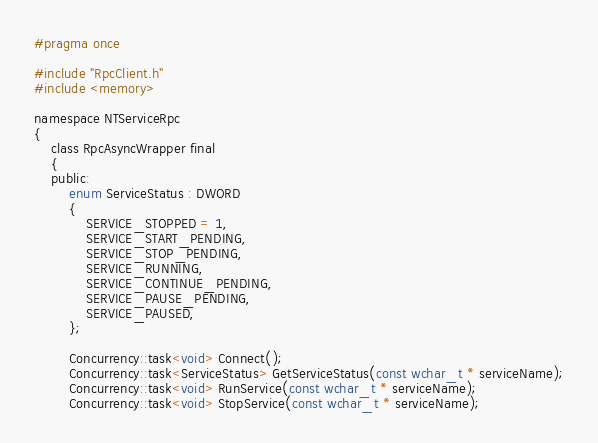<code> <loc_0><loc_0><loc_500><loc_500><_C_>#pragma once

#include "RpcClient.h"
#include <memory>

namespace NTServiceRpc
{
    class RpcAsyncWrapper final
    {
    public:
        enum ServiceStatus : DWORD
        {
            SERVICE_STOPPED = 1,
            SERVICE_START_PENDING,
            SERVICE_STOP_PENDING,
            SERVICE_RUNNING,
            SERVICE_CONTINUE_PENDING,
            SERVICE_PAUSE_PENDING,
            SERVICE_PAUSED,
        };

        Concurrency::task<void> Connect();
        Concurrency::task<ServiceStatus> GetServiceStatus(const wchar_t * serviceName);
        Concurrency::task<void> RunService(const wchar_t * serviceName);
        Concurrency::task<void> StopService(const wchar_t * serviceName);</code> 